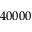<formula> <loc_0><loc_0><loc_500><loc_500>4 0 0 0 0</formula> 